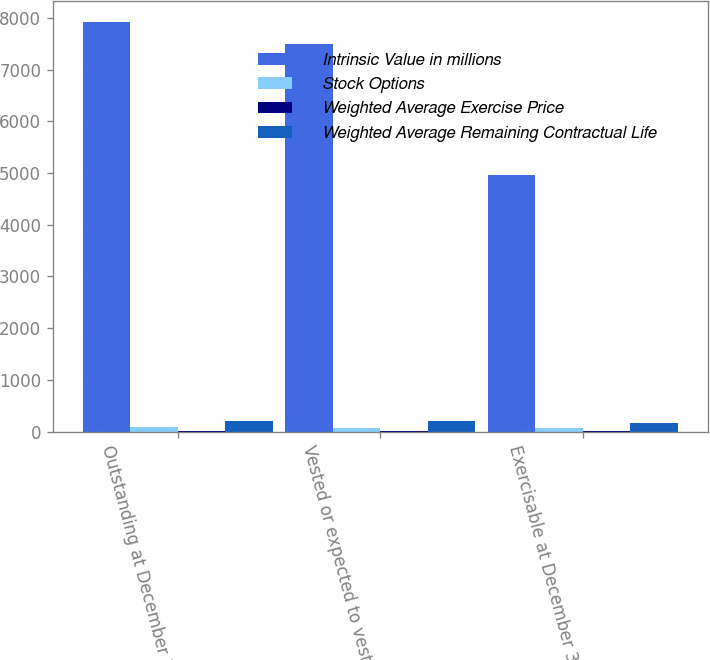<chart> <loc_0><loc_0><loc_500><loc_500><stacked_bar_chart><ecel><fcel>Outstanding at December 31<fcel>Vested or expected to vest as<fcel>Exercisable at December 31<nl><fcel>Intrinsic Value in millions<fcel>7931<fcel>7497<fcel>4969<nl><fcel>Stock Options<fcel>78.73<fcel>77.59<fcel>68.67<nl><fcel>Weighted Average Exercise Price<fcel>5.7<fcel>5.5<fcel>3.9<nl><fcel>Weighted Average Remaining Contractual Life<fcel>201.1<fcel>197.4<fcel>168.6<nl></chart> 